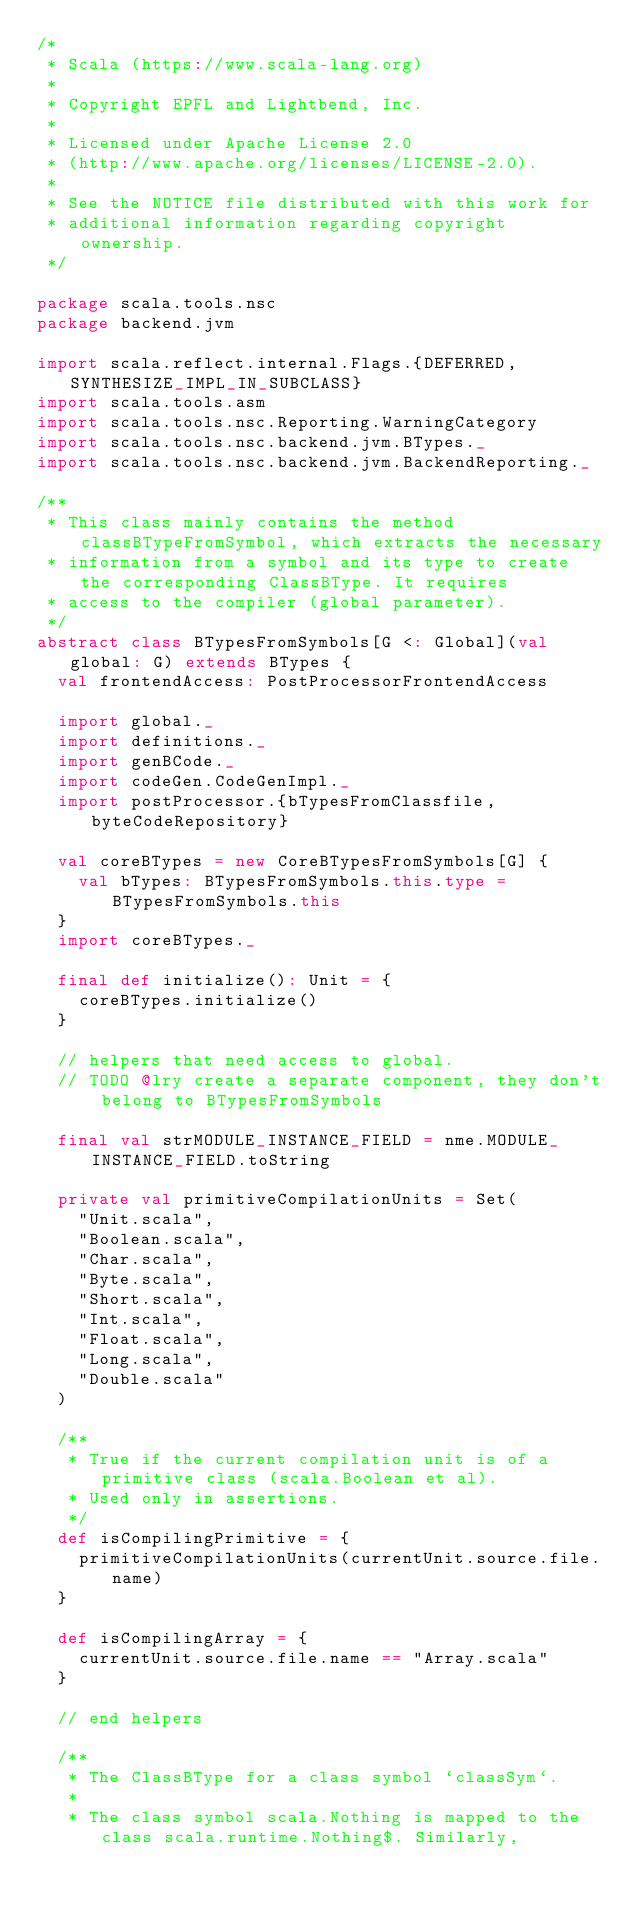Convert code to text. <code><loc_0><loc_0><loc_500><loc_500><_Scala_>/*
 * Scala (https://www.scala-lang.org)
 *
 * Copyright EPFL and Lightbend, Inc.
 *
 * Licensed under Apache License 2.0
 * (http://www.apache.org/licenses/LICENSE-2.0).
 *
 * See the NOTICE file distributed with this work for
 * additional information regarding copyright ownership.
 */

package scala.tools.nsc
package backend.jvm

import scala.reflect.internal.Flags.{DEFERRED, SYNTHESIZE_IMPL_IN_SUBCLASS}
import scala.tools.asm
import scala.tools.nsc.Reporting.WarningCategory
import scala.tools.nsc.backend.jvm.BTypes._
import scala.tools.nsc.backend.jvm.BackendReporting._

/**
 * This class mainly contains the method classBTypeFromSymbol, which extracts the necessary
 * information from a symbol and its type to create the corresponding ClassBType. It requires
 * access to the compiler (global parameter).
 */
abstract class BTypesFromSymbols[G <: Global](val global: G) extends BTypes {
  val frontendAccess: PostProcessorFrontendAccess

  import global._
  import definitions._
  import genBCode._
  import codeGen.CodeGenImpl._
  import postProcessor.{bTypesFromClassfile, byteCodeRepository}

  val coreBTypes = new CoreBTypesFromSymbols[G] {
    val bTypes: BTypesFromSymbols.this.type = BTypesFromSymbols.this
  }
  import coreBTypes._

  final def initialize(): Unit = {
    coreBTypes.initialize()
  }

  // helpers that need access to global.
  // TODO @lry create a separate component, they don't belong to BTypesFromSymbols

  final val strMODULE_INSTANCE_FIELD = nme.MODULE_INSTANCE_FIELD.toString

  private val primitiveCompilationUnits = Set(
    "Unit.scala",
    "Boolean.scala",
    "Char.scala",
    "Byte.scala",
    "Short.scala",
    "Int.scala",
    "Float.scala",
    "Long.scala",
    "Double.scala"
  )

  /**
   * True if the current compilation unit is of a primitive class (scala.Boolean et al).
   * Used only in assertions.
   */
  def isCompilingPrimitive = {
    primitiveCompilationUnits(currentUnit.source.file.name)
  }

  def isCompilingArray = {
    currentUnit.source.file.name == "Array.scala"
  }

  // end helpers

  /**
   * The ClassBType for a class symbol `classSym`.
   *
   * The class symbol scala.Nothing is mapped to the class scala.runtime.Nothing$. Similarly,</code> 